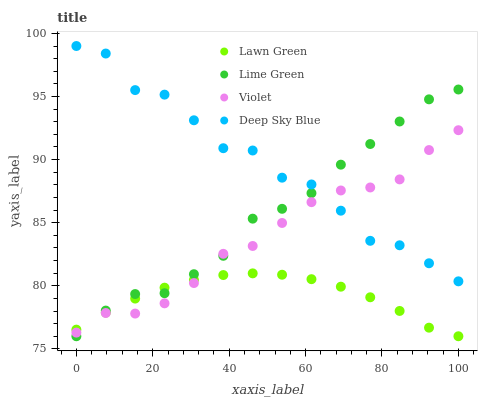Does Lawn Green have the minimum area under the curve?
Answer yes or no. Yes. Does Deep Sky Blue have the maximum area under the curve?
Answer yes or no. Yes. Does Lime Green have the minimum area under the curve?
Answer yes or no. No. Does Lime Green have the maximum area under the curve?
Answer yes or no. No. Is Lawn Green the smoothest?
Answer yes or no. Yes. Is Deep Sky Blue the roughest?
Answer yes or no. Yes. Is Lime Green the smoothest?
Answer yes or no. No. Is Lime Green the roughest?
Answer yes or no. No. Does Lawn Green have the lowest value?
Answer yes or no. Yes. Does Deep Sky Blue have the lowest value?
Answer yes or no. No. Does Deep Sky Blue have the highest value?
Answer yes or no. Yes. Does Lime Green have the highest value?
Answer yes or no. No. Is Lawn Green less than Deep Sky Blue?
Answer yes or no. Yes. Is Deep Sky Blue greater than Lawn Green?
Answer yes or no. Yes. Does Violet intersect Deep Sky Blue?
Answer yes or no. Yes. Is Violet less than Deep Sky Blue?
Answer yes or no. No. Is Violet greater than Deep Sky Blue?
Answer yes or no. No. Does Lawn Green intersect Deep Sky Blue?
Answer yes or no. No. 